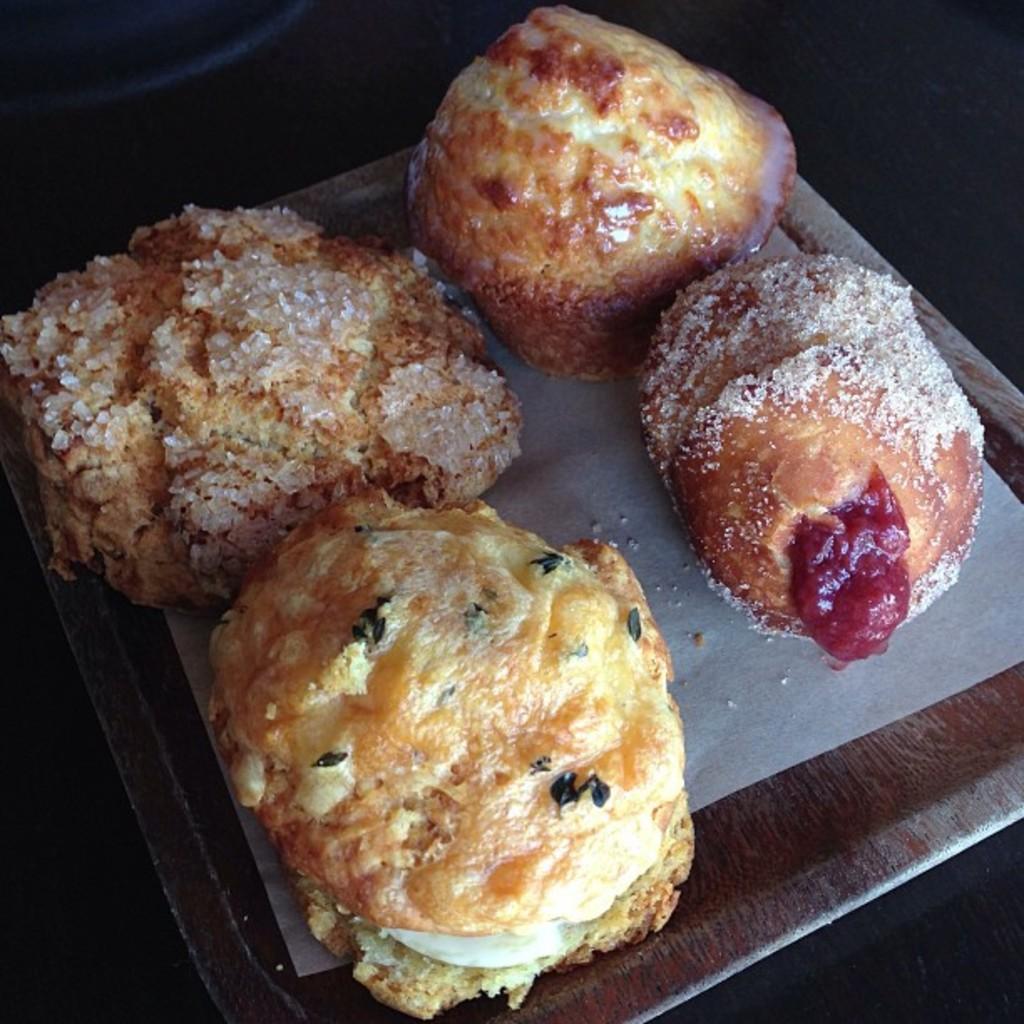How would you summarize this image in a sentence or two? In this picture I can see food item on the plate. 